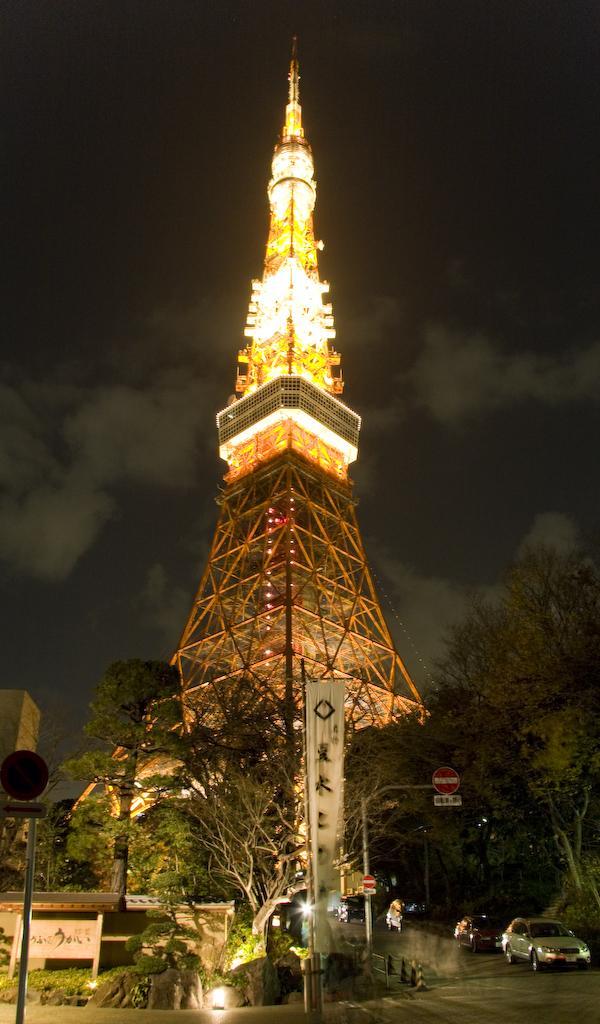In one or two sentences, can you explain what this image depicts? In this image there is a tower, on either side of the tower there are trees, in middle there is a road on that road vehicles are moving. 